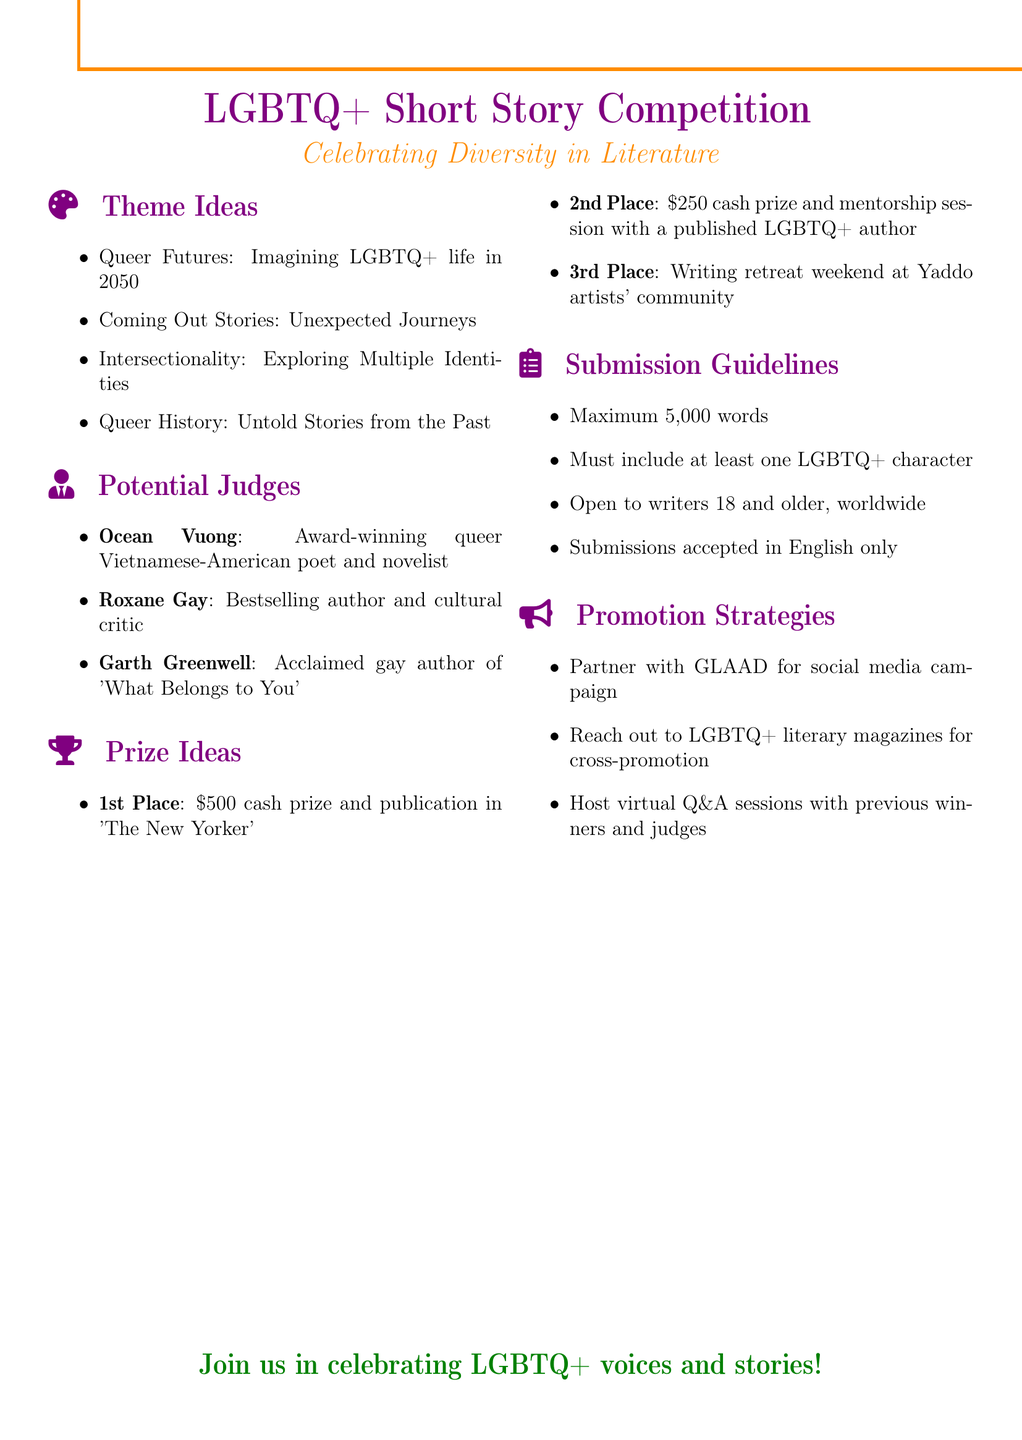What is the theme of the competition? The theme of the competition is specified in the document under "Theme Ideas."
Answer: LGBTQ+ Short Story Competition Who is the first potential judge listed? The first judge is mentioned under "Potential Judges," where their names and backgrounds are given.
Answer: Ocean Vuong What is the cash prize for the first place winner? The prize for first place is detailed in the "Prize Ideas" section of the document.
Answer: $500 How many words can submissions have at most? The maximum word limit for submissions is outlined in the "Submission Guidelines."
Answer: 5,000 words What organization is suggested for partnership in promotion? The promotion strategy mentions a specific organization for partnership.
Answer: GLAAD What type of document is this? The overall structure and content indicate the type of document it is.
Answer: Notes Which prize includes a mentorship session? The second place prize is described in the "Prize Ideas" section and includes a specific benefit.
Answer: mentorship session with a published LGBTQ+ author What must all submissions include? The requirements for submissions specify a particular condition regarding characters.
Answer: at least one LGBTQ+ character At what age can writers submit their works? The age requirement for writers is listed in the "Submission Guidelines."
Answer: 18 and older 